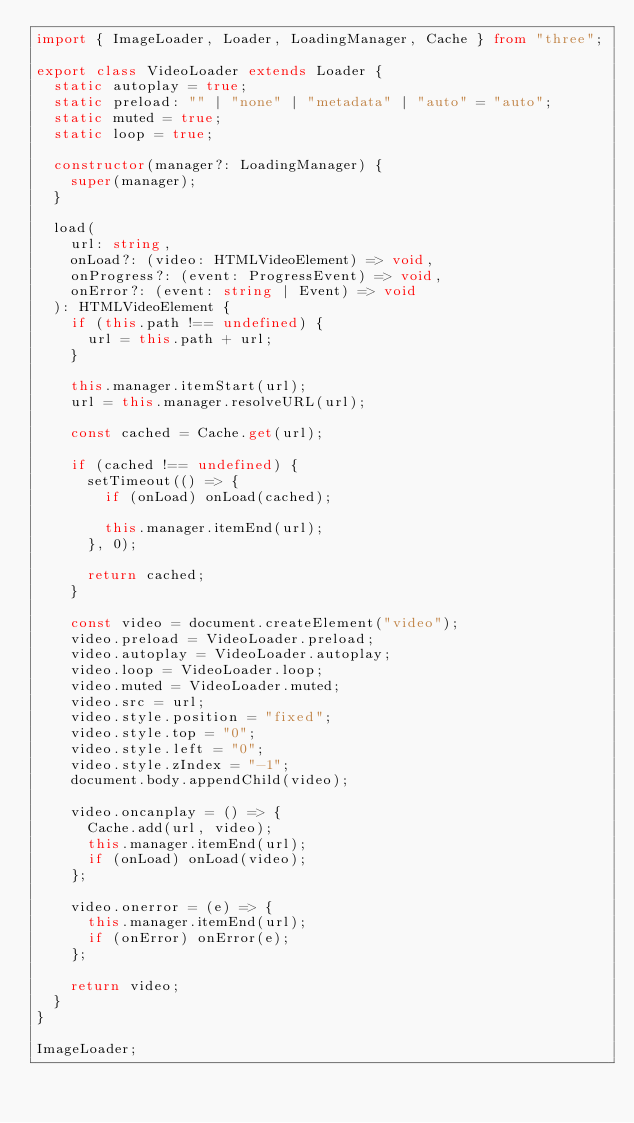Convert code to text. <code><loc_0><loc_0><loc_500><loc_500><_TypeScript_>import { ImageLoader, Loader, LoadingManager, Cache } from "three";

export class VideoLoader extends Loader {
  static autoplay = true;
  static preload: "" | "none" | "metadata" | "auto" = "auto";
  static muted = true;
  static loop = true;

  constructor(manager?: LoadingManager) {
    super(manager);
  }

  load(
    url: string,
    onLoad?: (video: HTMLVideoElement) => void,
    onProgress?: (event: ProgressEvent) => void,
    onError?: (event: string | Event) => void
  ): HTMLVideoElement {
    if (this.path !== undefined) {
      url = this.path + url;
    }

    this.manager.itemStart(url);
    url = this.manager.resolveURL(url);

    const cached = Cache.get(url);

    if (cached !== undefined) {
      setTimeout(() => {
        if (onLoad) onLoad(cached);

        this.manager.itemEnd(url);
      }, 0);

      return cached;
    }

    const video = document.createElement("video");
    video.preload = VideoLoader.preload;
    video.autoplay = VideoLoader.autoplay;
    video.loop = VideoLoader.loop;
    video.muted = VideoLoader.muted;
    video.src = url;
    video.style.position = "fixed";
    video.style.top = "0";
    video.style.left = "0";
    video.style.zIndex = "-1";
    document.body.appendChild(video);

    video.oncanplay = () => {
      Cache.add(url, video);
      this.manager.itemEnd(url);
      if (onLoad) onLoad(video);
    };

    video.onerror = (e) => {
      this.manager.itemEnd(url);
      if (onError) onError(e);
    };

    return video;
  }
}

ImageLoader;
</code> 